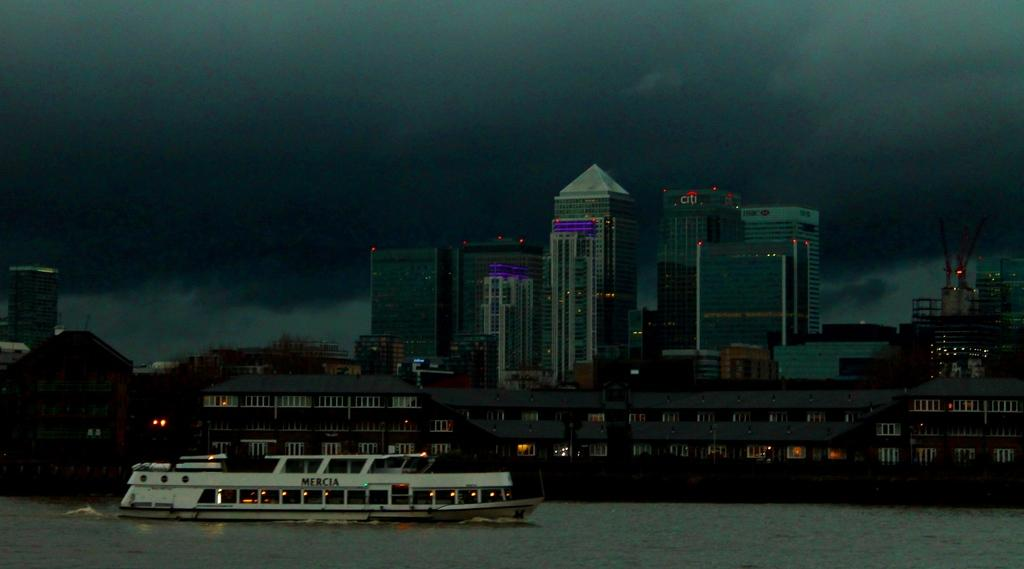<image>
Create a compact narrative representing the image presented. A boat with Mercia on it in front of a city skyline. 